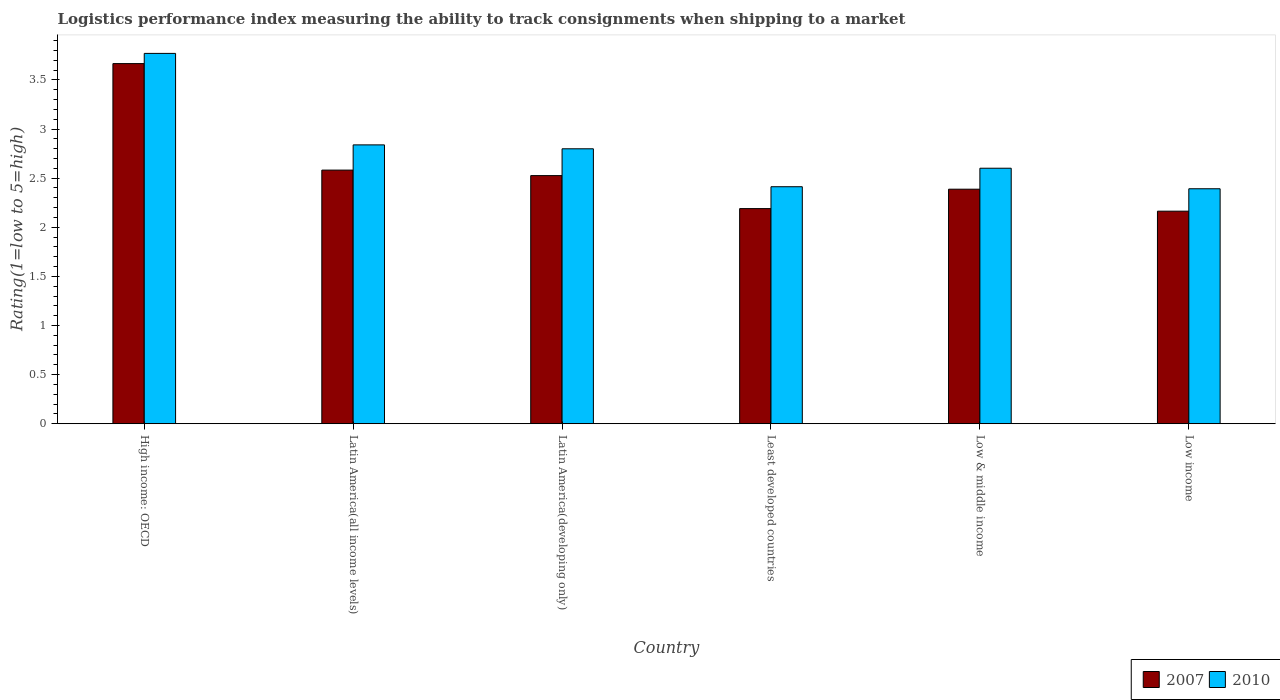How many different coloured bars are there?
Your answer should be compact. 2. Are the number of bars per tick equal to the number of legend labels?
Give a very brief answer. Yes. How many bars are there on the 2nd tick from the right?
Offer a very short reply. 2. What is the label of the 4th group of bars from the left?
Give a very brief answer. Least developed countries. In how many cases, is the number of bars for a given country not equal to the number of legend labels?
Keep it short and to the point. 0. What is the Logistic performance index in 2007 in Latin America(developing only)?
Offer a terse response. 2.53. Across all countries, what is the maximum Logistic performance index in 2010?
Offer a very short reply. 3.77. Across all countries, what is the minimum Logistic performance index in 2010?
Offer a very short reply. 2.39. In which country was the Logistic performance index in 2010 maximum?
Keep it short and to the point. High income: OECD. What is the total Logistic performance index in 2010 in the graph?
Make the answer very short. 16.81. What is the difference between the Logistic performance index in 2007 in Least developed countries and that in Low & middle income?
Give a very brief answer. -0.2. What is the difference between the Logistic performance index in 2007 in Latin America(all income levels) and the Logistic performance index in 2010 in Latin America(developing only)?
Offer a very short reply. -0.22. What is the average Logistic performance index in 2010 per country?
Make the answer very short. 2.8. What is the difference between the Logistic performance index of/in 2010 and Logistic performance index of/in 2007 in Low & middle income?
Your answer should be compact. 0.21. What is the ratio of the Logistic performance index in 2010 in Latin America(all income levels) to that in Low & middle income?
Provide a succinct answer. 1.09. Is the Logistic performance index in 2007 in High income: OECD less than that in Latin America(developing only)?
Offer a very short reply. No. What is the difference between the highest and the second highest Logistic performance index in 2007?
Keep it short and to the point. -1.08. What is the difference between the highest and the lowest Logistic performance index in 2010?
Offer a very short reply. 1.38. In how many countries, is the Logistic performance index in 2007 greater than the average Logistic performance index in 2007 taken over all countries?
Your answer should be very brief. 1. Is the sum of the Logistic performance index in 2007 in High income: OECD and Low & middle income greater than the maximum Logistic performance index in 2010 across all countries?
Your response must be concise. Yes. What does the 2nd bar from the right in Latin America(developing only) represents?
Give a very brief answer. 2007. What is the difference between two consecutive major ticks on the Y-axis?
Your answer should be very brief. 0.5. Does the graph contain grids?
Make the answer very short. No. Where does the legend appear in the graph?
Offer a very short reply. Bottom right. How are the legend labels stacked?
Make the answer very short. Horizontal. What is the title of the graph?
Provide a succinct answer. Logistics performance index measuring the ability to track consignments when shipping to a market. What is the label or title of the X-axis?
Your answer should be compact. Country. What is the label or title of the Y-axis?
Give a very brief answer. Rating(1=low to 5=high). What is the Rating(1=low to 5=high) of 2007 in High income: OECD?
Your answer should be compact. 3.67. What is the Rating(1=low to 5=high) in 2010 in High income: OECD?
Your response must be concise. 3.77. What is the Rating(1=low to 5=high) in 2007 in Latin America(all income levels)?
Keep it short and to the point. 2.58. What is the Rating(1=low to 5=high) in 2010 in Latin America(all income levels)?
Your answer should be compact. 2.84. What is the Rating(1=low to 5=high) in 2007 in Latin America(developing only)?
Offer a terse response. 2.53. What is the Rating(1=low to 5=high) of 2010 in Latin America(developing only)?
Keep it short and to the point. 2.8. What is the Rating(1=low to 5=high) in 2007 in Least developed countries?
Make the answer very short. 2.19. What is the Rating(1=low to 5=high) in 2010 in Least developed countries?
Your answer should be compact. 2.41. What is the Rating(1=low to 5=high) of 2007 in Low & middle income?
Make the answer very short. 2.39. What is the Rating(1=low to 5=high) of 2010 in Low & middle income?
Give a very brief answer. 2.6. What is the Rating(1=low to 5=high) of 2007 in Low income?
Provide a succinct answer. 2.16. What is the Rating(1=low to 5=high) of 2010 in Low income?
Offer a terse response. 2.39. Across all countries, what is the maximum Rating(1=low to 5=high) of 2007?
Provide a short and direct response. 3.67. Across all countries, what is the maximum Rating(1=low to 5=high) in 2010?
Provide a succinct answer. 3.77. Across all countries, what is the minimum Rating(1=low to 5=high) in 2007?
Make the answer very short. 2.16. Across all countries, what is the minimum Rating(1=low to 5=high) of 2010?
Your answer should be very brief. 2.39. What is the total Rating(1=low to 5=high) of 2007 in the graph?
Your answer should be compact. 15.52. What is the total Rating(1=low to 5=high) in 2010 in the graph?
Provide a succinct answer. 16.81. What is the difference between the Rating(1=low to 5=high) in 2007 in High income: OECD and that in Latin America(all income levels)?
Give a very brief answer. 1.08. What is the difference between the Rating(1=low to 5=high) of 2010 in High income: OECD and that in Latin America(all income levels)?
Ensure brevity in your answer.  0.93. What is the difference between the Rating(1=low to 5=high) in 2007 in High income: OECD and that in Latin America(developing only)?
Make the answer very short. 1.14. What is the difference between the Rating(1=low to 5=high) of 2010 in High income: OECD and that in Latin America(developing only)?
Ensure brevity in your answer.  0.97. What is the difference between the Rating(1=low to 5=high) of 2007 in High income: OECD and that in Least developed countries?
Offer a terse response. 1.48. What is the difference between the Rating(1=low to 5=high) of 2010 in High income: OECD and that in Least developed countries?
Ensure brevity in your answer.  1.36. What is the difference between the Rating(1=low to 5=high) of 2007 in High income: OECD and that in Low & middle income?
Give a very brief answer. 1.28. What is the difference between the Rating(1=low to 5=high) in 2010 in High income: OECD and that in Low & middle income?
Offer a very short reply. 1.17. What is the difference between the Rating(1=low to 5=high) in 2007 in High income: OECD and that in Low income?
Offer a terse response. 1.5. What is the difference between the Rating(1=low to 5=high) in 2010 in High income: OECD and that in Low income?
Give a very brief answer. 1.38. What is the difference between the Rating(1=low to 5=high) in 2007 in Latin America(all income levels) and that in Latin America(developing only)?
Provide a short and direct response. 0.06. What is the difference between the Rating(1=low to 5=high) of 2010 in Latin America(all income levels) and that in Latin America(developing only)?
Your answer should be very brief. 0.04. What is the difference between the Rating(1=low to 5=high) in 2007 in Latin America(all income levels) and that in Least developed countries?
Your answer should be very brief. 0.39. What is the difference between the Rating(1=low to 5=high) in 2010 in Latin America(all income levels) and that in Least developed countries?
Give a very brief answer. 0.43. What is the difference between the Rating(1=low to 5=high) in 2007 in Latin America(all income levels) and that in Low & middle income?
Offer a very short reply. 0.19. What is the difference between the Rating(1=low to 5=high) of 2010 in Latin America(all income levels) and that in Low & middle income?
Provide a succinct answer. 0.24. What is the difference between the Rating(1=low to 5=high) of 2007 in Latin America(all income levels) and that in Low income?
Provide a succinct answer. 0.42. What is the difference between the Rating(1=low to 5=high) of 2010 in Latin America(all income levels) and that in Low income?
Keep it short and to the point. 0.45. What is the difference between the Rating(1=low to 5=high) in 2007 in Latin America(developing only) and that in Least developed countries?
Give a very brief answer. 0.34. What is the difference between the Rating(1=low to 5=high) in 2010 in Latin America(developing only) and that in Least developed countries?
Offer a terse response. 0.39. What is the difference between the Rating(1=low to 5=high) in 2007 in Latin America(developing only) and that in Low & middle income?
Provide a short and direct response. 0.14. What is the difference between the Rating(1=low to 5=high) of 2010 in Latin America(developing only) and that in Low & middle income?
Your answer should be compact. 0.2. What is the difference between the Rating(1=low to 5=high) in 2007 in Latin America(developing only) and that in Low income?
Offer a very short reply. 0.36. What is the difference between the Rating(1=low to 5=high) in 2010 in Latin America(developing only) and that in Low income?
Your response must be concise. 0.41. What is the difference between the Rating(1=low to 5=high) of 2007 in Least developed countries and that in Low & middle income?
Keep it short and to the point. -0.2. What is the difference between the Rating(1=low to 5=high) of 2010 in Least developed countries and that in Low & middle income?
Offer a terse response. -0.19. What is the difference between the Rating(1=low to 5=high) of 2007 in Least developed countries and that in Low income?
Give a very brief answer. 0.03. What is the difference between the Rating(1=low to 5=high) in 2010 in Least developed countries and that in Low income?
Ensure brevity in your answer.  0.02. What is the difference between the Rating(1=low to 5=high) of 2007 in Low & middle income and that in Low income?
Ensure brevity in your answer.  0.22. What is the difference between the Rating(1=low to 5=high) of 2010 in Low & middle income and that in Low income?
Offer a terse response. 0.21. What is the difference between the Rating(1=low to 5=high) of 2007 in High income: OECD and the Rating(1=low to 5=high) of 2010 in Latin America(all income levels)?
Keep it short and to the point. 0.83. What is the difference between the Rating(1=low to 5=high) of 2007 in High income: OECD and the Rating(1=low to 5=high) of 2010 in Latin America(developing only)?
Offer a very short reply. 0.87. What is the difference between the Rating(1=low to 5=high) of 2007 in High income: OECD and the Rating(1=low to 5=high) of 2010 in Least developed countries?
Provide a short and direct response. 1.25. What is the difference between the Rating(1=low to 5=high) of 2007 in High income: OECD and the Rating(1=low to 5=high) of 2010 in Low & middle income?
Offer a terse response. 1.07. What is the difference between the Rating(1=low to 5=high) of 2007 in High income: OECD and the Rating(1=low to 5=high) of 2010 in Low income?
Provide a succinct answer. 1.27. What is the difference between the Rating(1=low to 5=high) of 2007 in Latin America(all income levels) and the Rating(1=low to 5=high) of 2010 in Latin America(developing only)?
Your response must be concise. -0.22. What is the difference between the Rating(1=low to 5=high) in 2007 in Latin America(all income levels) and the Rating(1=low to 5=high) in 2010 in Least developed countries?
Your answer should be compact. 0.17. What is the difference between the Rating(1=low to 5=high) in 2007 in Latin America(all income levels) and the Rating(1=low to 5=high) in 2010 in Low & middle income?
Ensure brevity in your answer.  -0.02. What is the difference between the Rating(1=low to 5=high) of 2007 in Latin America(all income levels) and the Rating(1=low to 5=high) of 2010 in Low income?
Ensure brevity in your answer.  0.19. What is the difference between the Rating(1=low to 5=high) in 2007 in Latin America(developing only) and the Rating(1=low to 5=high) in 2010 in Least developed countries?
Provide a succinct answer. 0.11. What is the difference between the Rating(1=low to 5=high) in 2007 in Latin America(developing only) and the Rating(1=low to 5=high) in 2010 in Low & middle income?
Give a very brief answer. -0.08. What is the difference between the Rating(1=low to 5=high) in 2007 in Latin America(developing only) and the Rating(1=low to 5=high) in 2010 in Low income?
Your answer should be very brief. 0.13. What is the difference between the Rating(1=low to 5=high) in 2007 in Least developed countries and the Rating(1=low to 5=high) in 2010 in Low & middle income?
Your response must be concise. -0.41. What is the difference between the Rating(1=low to 5=high) of 2007 in Least developed countries and the Rating(1=low to 5=high) of 2010 in Low income?
Make the answer very short. -0.2. What is the difference between the Rating(1=low to 5=high) in 2007 in Low & middle income and the Rating(1=low to 5=high) in 2010 in Low income?
Provide a short and direct response. -0. What is the average Rating(1=low to 5=high) in 2007 per country?
Your answer should be very brief. 2.59. What is the average Rating(1=low to 5=high) in 2010 per country?
Provide a succinct answer. 2.8. What is the difference between the Rating(1=low to 5=high) of 2007 and Rating(1=low to 5=high) of 2010 in High income: OECD?
Ensure brevity in your answer.  -0.1. What is the difference between the Rating(1=low to 5=high) of 2007 and Rating(1=low to 5=high) of 2010 in Latin America(all income levels)?
Your response must be concise. -0.26. What is the difference between the Rating(1=low to 5=high) in 2007 and Rating(1=low to 5=high) in 2010 in Latin America(developing only)?
Provide a short and direct response. -0.27. What is the difference between the Rating(1=low to 5=high) of 2007 and Rating(1=low to 5=high) of 2010 in Least developed countries?
Ensure brevity in your answer.  -0.22. What is the difference between the Rating(1=low to 5=high) of 2007 and Rating(1=low to 5=high) of 2010 in Low & middle income?
Offer a terse response. -0.21. What is the difference between the Rating(1=low to 5=high) in 2007 and Rating(1=low to 5=high) in 2010 in Low income?
Keep it short and to the point. -0.23. What is the ratio of the Rating(1=low to 5=high) in 2007 in High income: OECD to that in Latin America(all income levels)?
Offer a very short reply. 1.42. What is the ratio of the Rating(1=low to 5=high) of 2010 in High income: OECD to that in Latin America(all income levels)?
Make the answer very short. 1.33. What is the ratio of the Rating(1=low to 5=high) of 2007 in High income: OECD to that in Latin America(developing only)?
Offer a terse response. 1.45. What is the ratio of the Rating(1=low to 5=high) in 2010 in High income: OECD to that in Latin America(developing only)?
Your answer should be very brief. 1.35. What is the ratio of the Rating(1=low to 5=high) in 2007 in High income: OECD to that in Least developed countries?
Your answer should be compact. 1.67. What is the ratio of the Rating(1=low to 5=high) of 2010 in High income: OECD to that in Least developed countries?
Ensure brevity in your answer.  1.56. What is the ratio of the Rating(1=low to 5=high) in 2007 in High income: OECD to that in Low & middle income?
Ensure brevity in your answer.  1.54. What is the ratio of the Rating(1=low to 5=high) of 2010 in High income: OECD to that in Low & middle income?
Your answer should be very brief. 1.45. What is the ratio of the Rating(1=low to 5=high) of 2007 in High income: OECD to that in Low income?
Offer a terse response. 1.69. What is the ratio of the Rating(1=low to 5=high) of 2010 in High income: OECD to that in Low income?
Offer a terse response. 1.58. What is the ratio of the Rating(1=low to 5=high) in 2007 in Latin America(all income levels) to that in Latin America(developing only)?
Provide a succinct answer. 1.02. What is the ratio of the Rating(1=low to 5=high) of 2010 in Latin America(all income levels) to that in Latin America(developing only)?
Your response must be concise. 1.01. What is the ratio of the Rating(1=low to 5=high) in 2007 in Latin America(all income levels) to that in Least developed countries?
Make the answer very short. 1.18. What is the ratio of the Rating(1=low to 5=high) in 2010 in Latin America(all income levels) to that in Least developed countries?
Provide a succinct answer. 1.18. What is the ratio of the Rating(1=low to 5=high) in 2007 in Latin America(all income levels) to that in Low & middle income?
Provide a succinct answer. 1.08. What is the ratio of the Rating(1=low to 5=high) in 2010 in Latin America(all income levels) to that in Low & middle income?
Your response must be concise. 1.09. What is the ratio of the Rating(1=low to 5=high) of 2007 in Latin America(all income levels) to that in Low income?
Provide a short and direct response. 1.19. What is the ratio of the Rating(1=low to 5=high) in 2010 in Latin America(all income levels) to that in Low income?
Your answer should be very brief. 1.19. What is the ratio of the Rating(1=low to 5=high) of 2007 in Latin America(developing only) to that in Least developed countries?
Make the answer very short. 1.15. What is the ratio of the Rating(1=low to 5=high) in 2010 in Latin America(developing only) to that in Least developed countries?
Offer a very short reply. 1.16. What is the ratio of the Rating(1=low to 5=high) in 2007 in Latin America(developing only) to that in Low & middle income?
Keep it short and to the point. 1.06. What is the ratio of the Rating(1=low to 5=high) in 2010 in Latin America(developing only) to that in Low & middle income?
Offer a terse response. 1.08. What is the ratio of the Rating(1=low to 5=high) in 2007 in Latin America(developing only) to that in Low income?
Ensure brevity in your answer.  1.17. What is the ratio of the Rating(1=low to 5=high) in 2010 in Latin America(developing only) to that in Low income?
Provide a short and direct response. 1.17. What is the ratio of the Rating(1=low to 5=high) in 2007 in Least developed countries to that in Low & middle income?
Give a very brief answer. 0.92. What is the ratio of the Rating(1=low to 5=high) in 2010 in Least developed countries to that in Low & middle income?
Provide a short and direct response. 0.93. What is the ratio of the Rating(1=low to 5=high) in 2007 in Least developed countries to that in Low income?
Your answer should be compact. 1.01. What is the ratio of the Rating(1=low to 5=high) of 2010 in Least developed countries to that in Low income?
Keep it short and to the point. 1.01. What is the ratio of the Rating(1=low to 5=high) of 2007 in Low & middle income to that in Low income?
Your answer should be compact. 1.1. What is the ratio of the Rating(1=low to 5=high) of 2010 in Low & middle income to that in Low income?
Offer a very short reply. 1.09. What is the difference between the highest and the second highest Rating(1=low to 5=high) in 2007?
Provide a succinct answer. 1.08. What is the difference between the highest and the second highest Rating(1=low to 5=high) in 2010?
Ensure brevity in your answer.  0.93. What is the difference between the highest and the lowest Rating(1=low to 5=high) of 2007?
Offer a very short reply. 1.5. What is the difference between the highest and the lowest Rating(1=low to 5=high) of 2010?
Offer a very short reply. 1.38. 